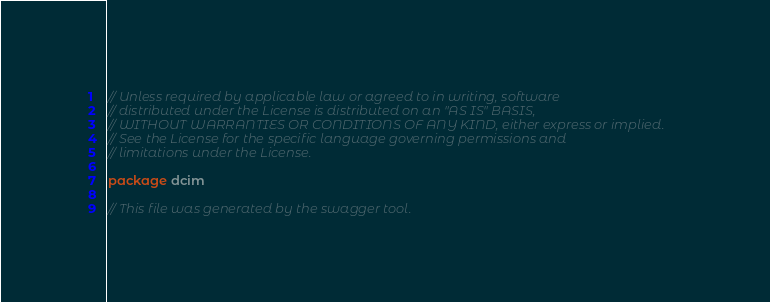<code> <loc_0><loc_0><loc_500><loc_500><_Go_>// Unless required by applicable law or agreed to in writing, software
// distributed under the License is distributed on an "AS IS" BASIS,
// WITHOUT WARRANTIES OR CONDITIONS OF ANY KIND, either express or implied.
// See the License for the specific language governing permissions and
// limitations under the License.

package dcim

// This file was generated by the swagger tool.</code> 